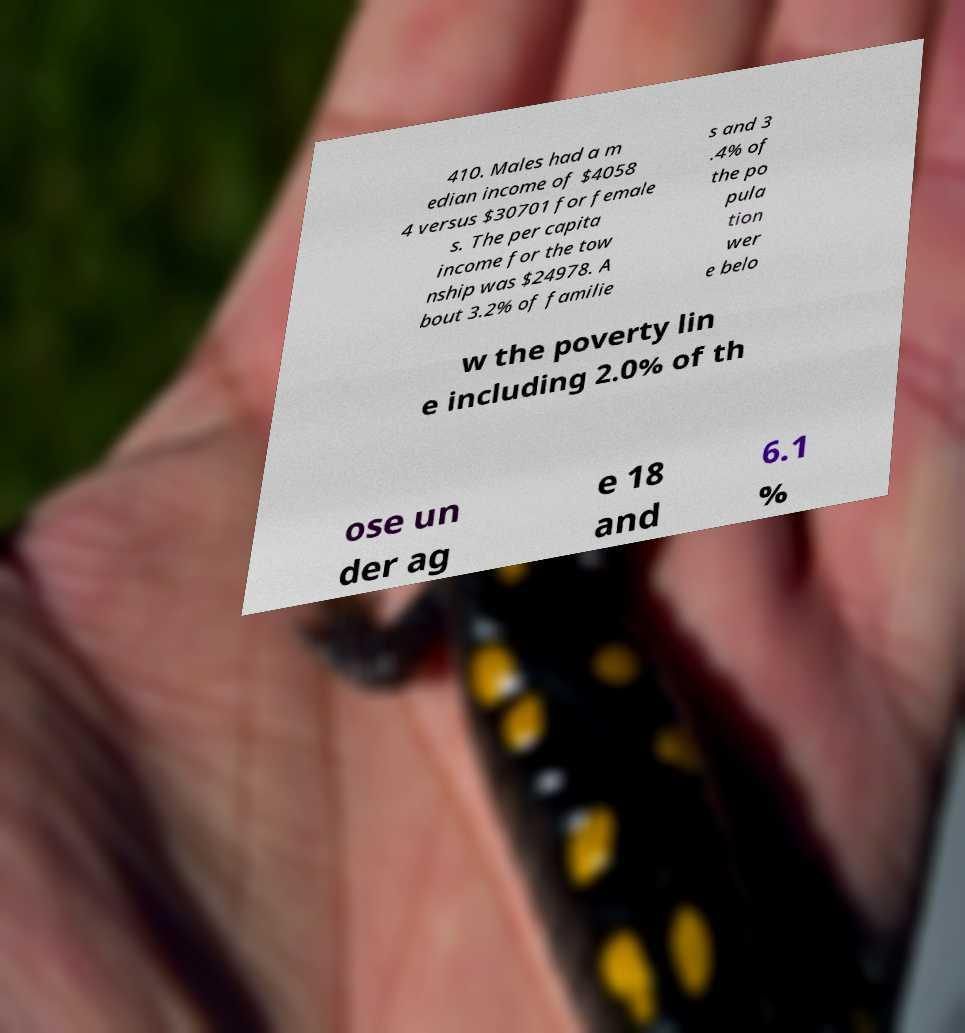For documentation purposes, I need the text within this image transcribed. Could you provide that? 410. Males had a m edian income of $4058 4 versus $30701 for female s. The per capita income for the tow nship was $24978. A bout 3.2% of familie s and 3 .4% of the po pula tion wer e belo w the poverty lin e including 2.0% of th ose un der ag e 18 and 6.1 % 